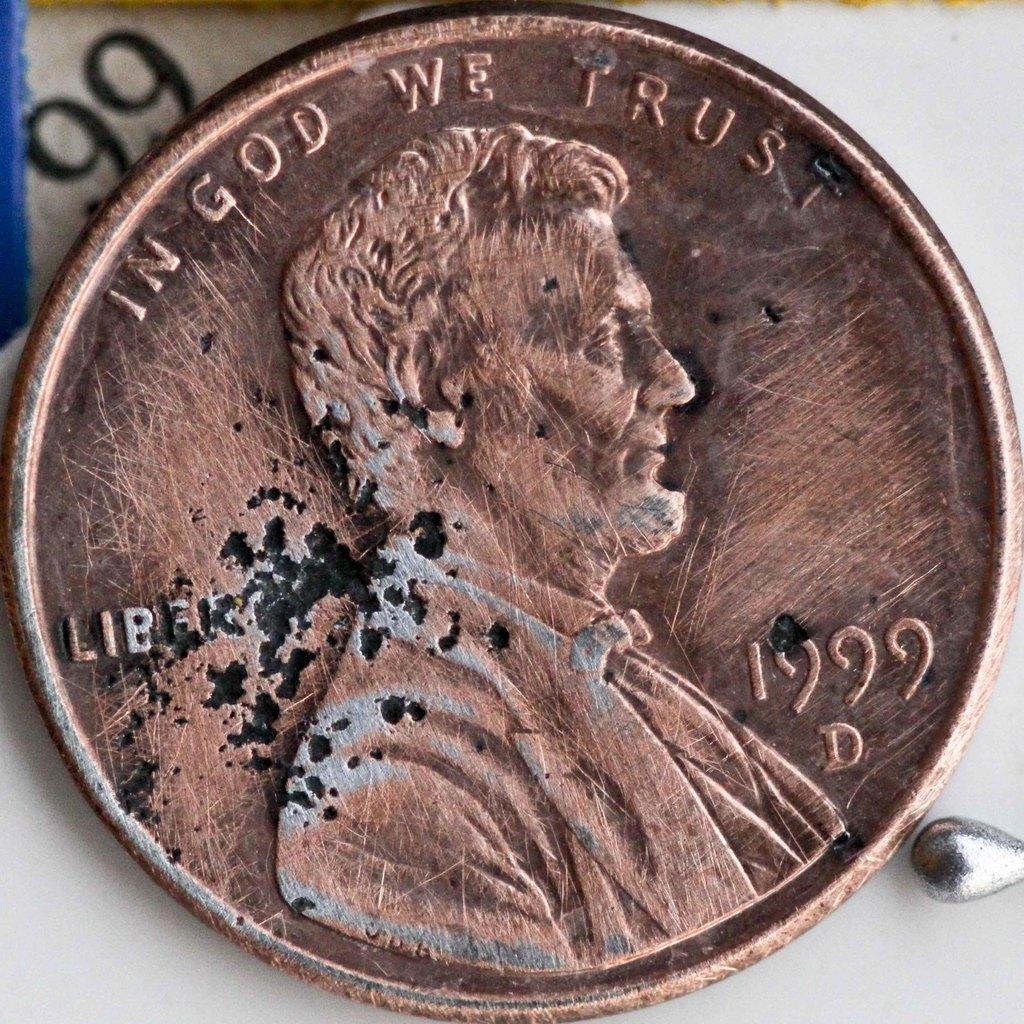What is written at the top of the coin?'?
Make the answer very short. In god we trust. What year is the penny?
Give a very brief answer. 1999. 